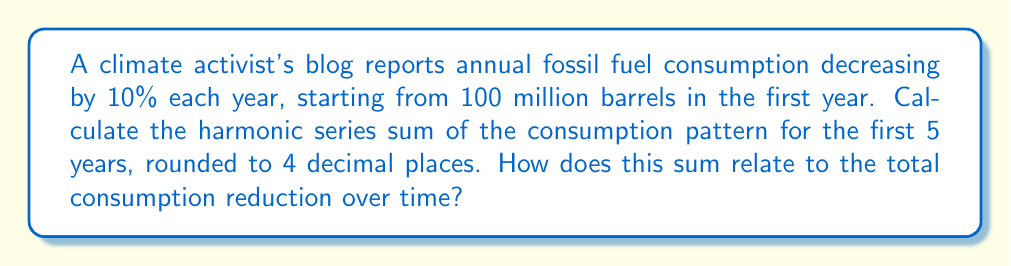What is the answer to this math problem? Let's approach this step-by-step:

1) The consumption pattern for 5 years is:
   Year 1: 100 million barrels
   Year 2: 90 million barrels
   Year 3: 81 million barrels
   Year 4: 72.9 million barrels
   Year 5: 65.61 million barrels

2) The harmonic series sum is calculated as:
   $$H = \frac{1}{a_1} + \frac{1}{a_2} + \frac{1}{a_3} + \frac{1}{a_4} + \frac{1}{a_5}$$

3) Substituting our values:
   $$H = \frac{1}{100} + \frac{1}{90} + \frac{1}{81} + \frac{1}{72.9} + \frac{1}{65.61}$$

4) Calculate each term:
   $$H = 0.01 + 0.0111111... + 0.0123456... + 0.0137174... + 0.0152414...$$

5) Sum these values:
   $$H = 0.0624156...$$

6) Rounding to 4 decimal places:
   $$H \approx 0.0624$$

7) Interpretation: This sum represents the rate of consumption reduction. A larger harmonic sum indicates a faster overall rate of decrease in fossil fuel consumption, which aligns with the activist's goal of promoting divestment from fossil fuels.
Answer: 0.0624 